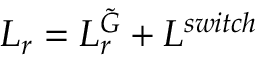<formula> <loc_0><loc_0><loc_500><loc_500>L _ { r } = L _ { r } ^ { \tilde { G } } + L ^ { s w i t c h }</formula> 